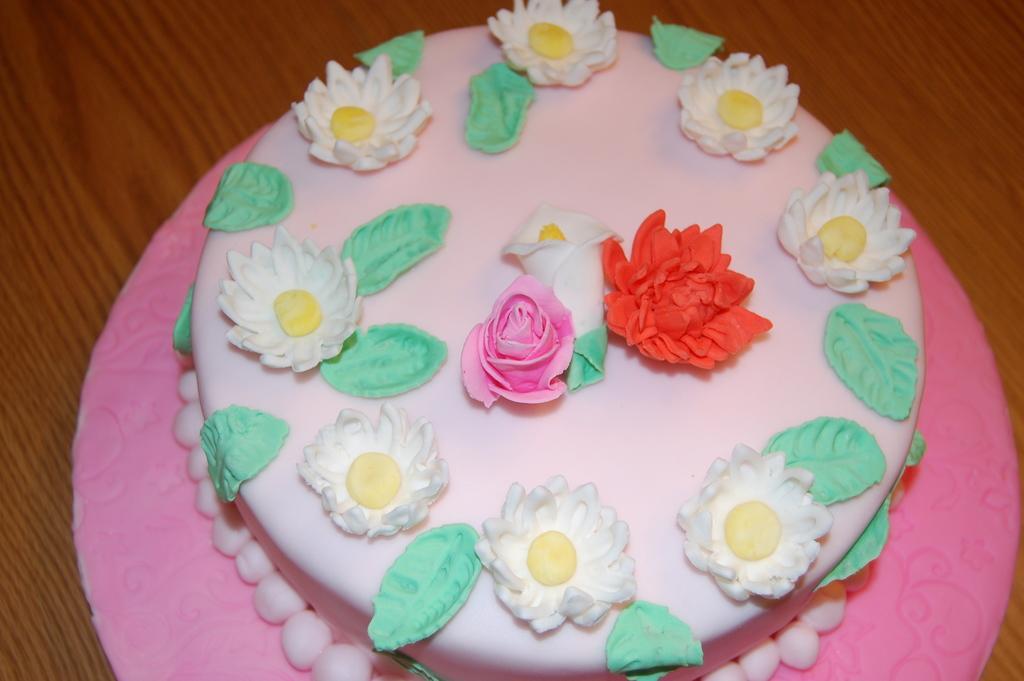Describe this image in one or two sentences. This image consists of a cake on which we can see flowers and leaves made up of cream. The flowers are in white red and pink colors. The leaves are in green color. At the bottom, there is a table. 